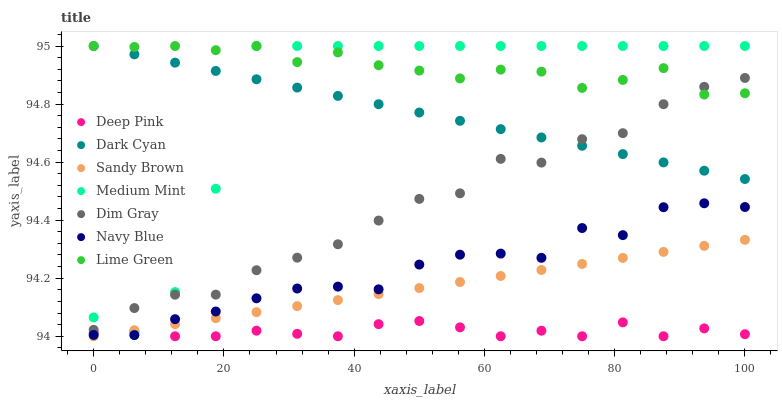Does Deep Pink have the minimum area under the curve?
Answer yes or no. Yes. Does Lime Green have the maximum area under the curve?
Answer yes or no. Yes. Does Dim Gray have the minimum area under the curve?
Answer yes or no. No. Does Dim Gray have the maximum area under the curve?
Answer yes or no. No. Is Sandy Brown the smoothest?
Answer yes or no. Yes. Is Medium Mint the roughest?
Answer yes or no. Yes. Is Dim Gray the smoothest?
Answer yes or no. No. Is Dim Gray the roughest?
Answer yes or no. No. Does Deep Pink have the lowest value?
Answer yes or no. Yes. Does Dim Gray have the lowest value?
Answer yes or no. No. Does Dark Cyan have the highest value?
Answer yes or no. Yes. Does Dim Gray have the highest value?
Answer yes or no. No. Is Navy Blue less than Lime Green?
Answer yes or no. Yes. Is Lime Green greater than Navy Blue?
Answer yes or no. Yes. Does Sandy Brown intersect Navy Blue?
Answer yes or no. Yes. Is Sandy Brown less than Navy Blue?
Answer yes or no. No. Is Sandy Brown greater than Navy Blue?
Answer yes or no. No. Does Navy Blue intersect Lime Green?
Answer yes or no. No. 